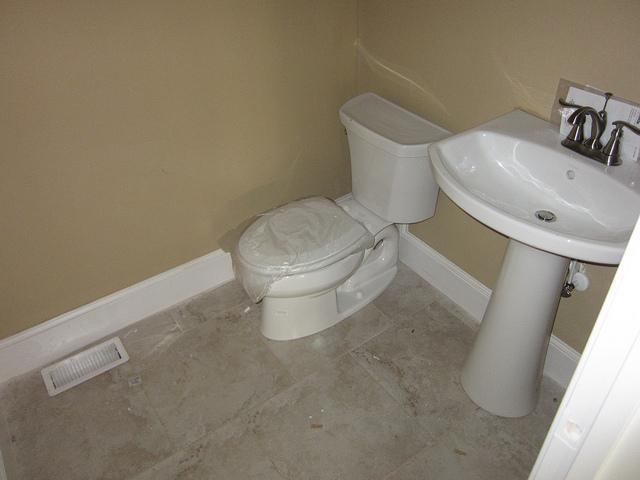How many toilets are pictured?
Give a very brief answer. 1. How many sinks are there?
Give a very brief answer. 1. 